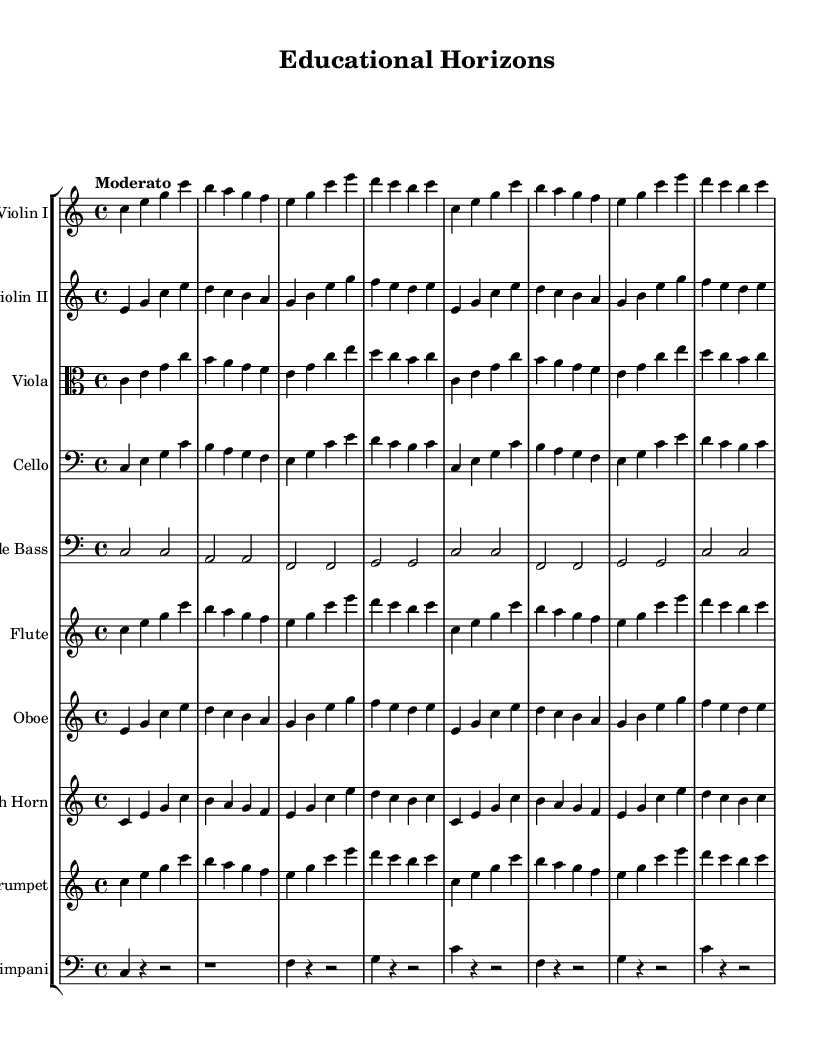What is the key signature of this music? The key signature is indicated at the beginning of the sheet music, and it shows no sharps or flats, which corresponds to C major.
Answer: C major What is the time signature of this music? The time signature appears at the beginning of the sheet music; it is represented by a "4/4," indicating there are four beats per measure.
Answer: 4/4 What is the tempo marking of this piece? The tempo is specified at the beginning of the music with the word "Moderato," which suggests a moderate speed, neither fast nor slow.
Answer: Moderato Which instruments are featured in this orchestral piece? The sheet music displays multiple staves, each labeled with an instrument name: Violin I, Violin II, Viola, Cello, Double Bass, Flute, Oboe, French Horn, Trumpet, and Timpani, indicating a full orchestral arrangement.
Answer: Violin I, Violin II, Viola, Cello, Double Bass, Flute, Oboe, French Horn, Trumpet, Timpani How many measures are present in the first section of the music? By counting the divided sections created by the vertical lines (barlines), there are eight measures in the first section, as indicated by the notated structure.
Answer: 8 What is the melodic range of the Viola part? Reviewing the notes written for the Viola shows it generally stays within the C' to E' range, which indicates a moderate melodic range throughout the piece.
Answer: C' to E' 